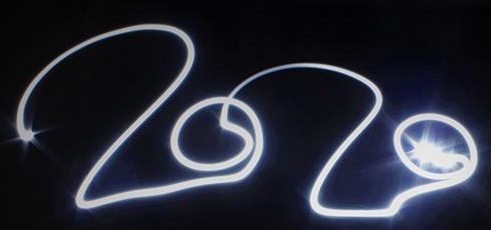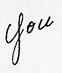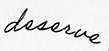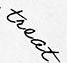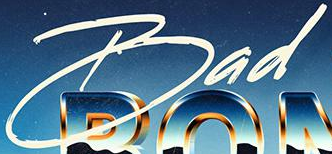Identify the words shown in these images in order, separated by a semicolon. 2020; you; deserve; treat; Bad 